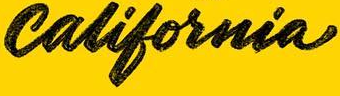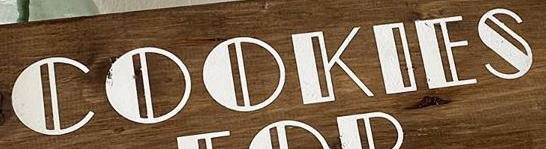What words can you see in these images in sequence, separated by a semicolon? california; COOKIES 